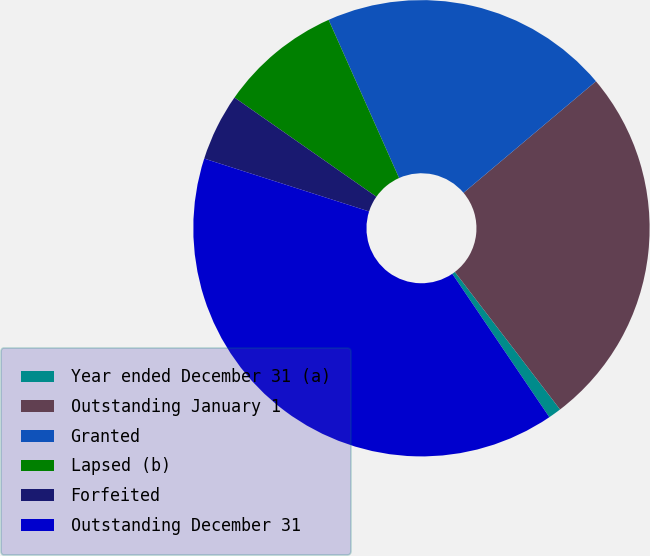<chart> <loc_0><loc_0><loc_500><loc_500><pie_chart><fcel>Year ended December 31 (a)<fcel>Outstanding January 1<fcel>Granted<fcel>Lapsed (b)<fcel>Forfeited<fcel>Outstanding December 31<nl><fcel>0.92%<fcel>25.75%<fcel>20.53%<fcel>8.62%<fcel>4.77%<fcel>39.41%<nl></chart> 